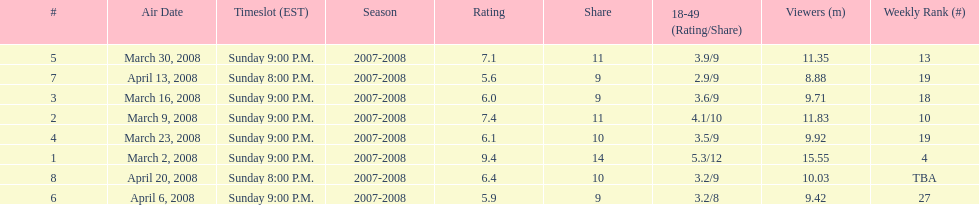The air date with the most viewers March 2, 2008. 